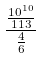Convert formula to latex. <formula><loc_0><loc_0><loc_500><loc_500>\frac { \frac { 1 0 ^ { 1 0 } } { 1 1 3 } } { \frac { 4 } { 6 } }</formula> 